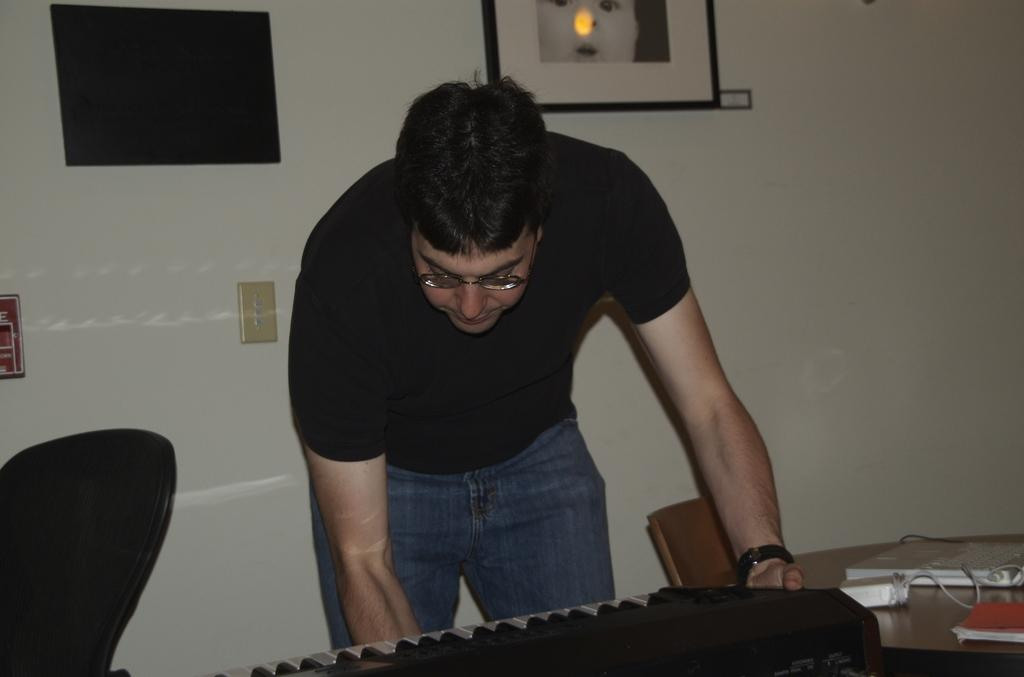What is the main subject of the image? There is a person standing in the image. What object is in front of the person? There is a piano in front of the person. What can be seen on the table in the image? There is a book on a table in the image. What type of furniture is present in the image? There is a chair in the image. What is visible at the back of the image? There is a frame at the back side of the image. What type of duck can be seen drinking from a vacation spot in the image? There is no duck, drink, or vacation spot present in the image. 